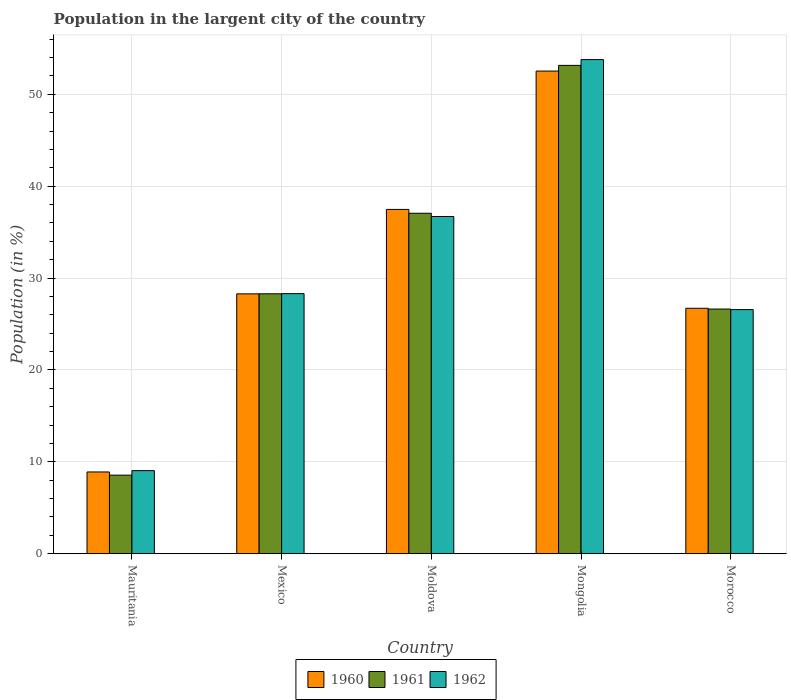How many different coloured bars are there?
Keep it short and to the point. 3. How many groups of bars are there?
Make the answer very short. 5. How many bars are there on the 4th tick from the left?
Your answer should be very brief. 3. How many bars are there on the 1st tick from the right?
Ensure brevity in your answer.  3. What is the label of the 4th group of bars from the left?
Offer a very short reply. Mongolia. In how many cases, is the number of bars for a given country not equal to the number of legend labels?
Your response must be concise. 0. What is the percentage of population in the largent city in 1960 in Mauritania?
Provide a short and direct response. 8.9. Across all countries, what is the maximum percentage of population in the largent city in 1961?
Provide a succinct answer. 53.14. Across all countries, what is the minimum percentage of population in the largent city in 1960?
Make the answer very short. 8.9. In which country was the percentage of population in the largent city in 1962 maximum?
Your answer should be compact. Mongolia. In which country was the percentage of population in the largent city in 1960 minimum?
Your answer should be very brief. Mauritania. What is the total percentage of population in the largent city in 1960 in the graph?
Your answer should be very brief. 153.88. What is the difference between the percentage of population in the largent city in 1962 in Mauritania and that in Moldova?
Ensure brevity in your answer.  -27.65. What is the difference between the percentage of population in the largent city in 1961 in Mexico and the percentage of population in the largent city in 1962 in Mongolia?
Ensure brevity in your answer.  -25.49. What is the average percentage of population in the largent city in 1962 per country?
Provide a succinct answer. 30.88. What is the difference between the percentage of population in the largent city of/in 1962 and percentage of population in the largent city of/in 1961 in Mongolia?
Your response must be concise. 0.63. What is the ratio of the percentage of population in the largent city in 1962 in Mexico to that in Moldova?
Offer a terse response. 0.77. What is the difference between the highest and the second highest percentage of population in the largent city in 1961?
Provide a succinct answer. 8.76. What is the difference between the highest and the lowest percentage of population in the largent city in 1961?
Provide a short and direct response. 44.59. What does the 2nd bar from the left in Mauritania represents?
Provide a short and direct response. 1961. How many bars are there?
Your answer should be very brief. 15. Does the graph contain any zero values?
Offer a terse response. No. Where does the legend appear in the graph?
Provide a short and direct response. Bottom center. How many legend labels are there?
Keep it short and to the point. 3. What is the title of the graph?
Your answer should be very brief. Population in the largent city of the country. Does "1986" appear as one of the legend labels in the graph?
Ensure brevity in your answer.  No. What is the Population (in %) in 1960 in Mauritania?
Offer a very short reply. 8.9. What is the Population (in %) in 1961 in Mauritania?
Provide a short and direct response. 8.55. What is the Population (in %) of 1962 in Mauritania?
Give a very brief answer. 9.04. What is the Population (in %) of 1960 in Mexico?
Make the answer very short. 28.28. What is the Population (in %) of 1961 in Mexico?
Give a very brief answer. 28.29. What is the Population (in %) in 1962 in Mexico?
Give a very brief answer. 28.31. What is the Population (in %) of 1960 in Moldova?
Provide a short and direct response. 37.47. What is the Population (in %) of 1961 in Moldova?
Provide a succinct answer. 37.05. What is the Population (in %) in 1962 in Moldova?
Give a very brief answer. 36.7. What is the Population (in %) in 1960 in Mongolia?
Provide a succinct answer. 52.52. What is the Population (in %) of 1961 in Mongolia?
Provide a short and direct response. 53.14. What is the Population (in %) in 1962 in Mongolia?
Your answer should be compact. 53.77. What is the Population (in %) in 1960 in Morocco?
Your answer should be very brief. 26.71. What is the Population (in %) of 1961 in Morocco?
Give a very brief answer. 26.63. What is the Population (in %) of 1962 in Morocco?
Keep it short and to the point. 26.57. Across all countries, what is the maximum Population (in %) of 1960?
Keep it short and to the point. 52.52. Across all countries, what is the maximum Population (in %) in 1961?
Provide a short and direct response. 53.14. Across all countries, what is the maximum Population (in %) in 1962?
Give a very brief answer. 53.77. Across all countries, what is the minimum Population (in %) of 1960?
Your answer should be compact. 8.9. Across all countries, what is the minimum Population (in %) in 1961?
Provide a succinct answer. 8.55. Across all countries, what is the minimum Population (in %) of 1962?
Your answer should be very brief. 9.04. What is the total Population (in %) of 1960 in the graph?
Your answer should be compact. 153.88. What is the total Population (in %) in 1961 in the graph?
Keep it short and to the point. 153.66. What is the total Population (in %) of 1962 in the graph?
Give a very brief answer. 154.39. What is the difference between the Population (in %) of 1960 in Mauritania and that in Mexico?
Make the answer very short. -19.38. What is the difference between the Population (in %) of 1961 in Mauritania and that in Mexico?
Your response must be concise. -19.73. What is the difference between the Population (in %) of 1962 in Mauritania and that in Mexico?
Provide a succinct answer. -19.26. What is the difference between the Population (in %) of 1960 in Mauritania and that in Moldova?
Ensure brevity in your answer.  -28.57. What is the difference between the Population (in %) in 1961 in Mauritania and that in Moldova?
Keep it short and to the point. -28.5. What is the difference between the Population (in %) in 1962 in Mauritania and that in Moldova?
Provide a succinct answer. -27.66. What is the difference between the Population (in %) of 1960 in Mauritania and that in Mongolia?
Ensure brevity in your answer.  -43.62. What is the difference between the Population (in %) of 1961 in Mauritania and that in Mongolia?
Offer a very short reply. -44.59. What is the difference between the Population (in %) of 1962 in Mauritania and that in Mongolia?
Make the answer very short. -44.73. What is the difference between the Population (in %) of 1960 in Mauritania and that in Morocco?
Provide a succinct answer. -17.81. What is the difference between the Population (in %) in 1961 in Mauritania and that in Morocco?
Provide a succinct answer. -18.08. What is the difference between the Population (in %) in 1962 in Mauritania and that in Morocco?
Your answer should be very brief. -17.53. What is the difference between the Population (in %) in 1960 in Mexico and that in Moldova?
Make the answer very short. -9.19. What is the difference between the Population (in %) in 1961 in Mexico and that in Moldova?
Offer a terse response. -8.76. What is the difference between the Population (in %) of 1962 in Mexico and that in Moldova?
Your answer should be very brief. -8.39. What is the difference between the Population (in %) in 1960 in Mexico and that in Mongolia?
Your answer should be very brief. -24.24. What is the difference between the Population (in %) of 1961 in Mexico and that in Mongolia?
Your response must be concise. -24.86. What is the difference between the Population (in %) in 1962 in Mexico and that in Mongolia?
Provide a succinct answer. -25.47. What is the difference between the Population (in %) in 1960 in Mexico and that in Morocco?
Offer a terse response. 1.57. What is the difference between the Population (in %) of 1961 in Mexico and that in Morocco?
Ensure brevity in your answer.  1.66. What is the difference between the Population (in %) of 1962 in Mexico and that in Morocco?
Your response must be concise. 1.74. What is the difference between the Population (in %) in 1960 in Moldova and that in Mongolia?
Offer a terse response. -15.05. What is the difference between the Population (in %) in 1961 in Moldova and that in Mongolia?
Keep it short and to the point. -16.09. What is the difference between the Population (in %) of 1962 in Moldova and that in Mongolia?
Your answer should be very brief. -17.08. What is the difference between the Population (in %) of 1960 in Moldova and that in Morocco?
Your answer should be very brief. 10.76. What is the difference between the Population (in %) in 1961 in Moldova and that in Morocco?
Give a very brief answer. 10.42. What is the difference between the Population (in %) in 1962 in Moldova and that in Morocco?
Your answer should be very brief. 10.13. What is the difference between the Population (in %) of 1960 in Mongolia and that in Morocco?
Your response must be concise. 25.81. What is the difference between the Population (in %) of 1961 in Mongolia and that in Morocco?
Give a very brief answer. 26.51. What is the difference between the Population (in %) in 1962 in Mongolia and that in Morocco?
Make the answer very short. 27.2. What is the difference between the Population (in %) in 1960 in Mauritania and the Population (in %) in 1961 in Mexico?
Your answer should be very brief. -19.39. What is the difference between the Population (in %) in 1960 in Mauritania and the Population (in %) in 1962 in Mexico?
Give a very brief answer. -19.41. What is the difference between the Population (in %) in 1961 in Mauritania and the Population (in %) in 1962 in Mexico?
Your answer should be compact. -19.75. What is the difference between the Population (in %) of 1960 in Mauritania and the Population (in %) of 1961 in Moldova?
Your response must be concise. -28.15. What is the difference between the Population (in %) of 1960 in Mauritania and the Population (in %) of 1962 in Moldova?
Provide a short and direct response. -27.8. What is the difference between the Population (in %) in 1961 in Mauritania and the Population (in %) in 1962 in Moldova?
Offer a terse response. -28.15. What is the difference between the Population (in %) of 1960 in Mauritania and the Population (in %) of 1961 in Mongolia?
Make the answer very short. -44.24. What is the difference between the Population (in %) of 1960 in Mauritania and the Population (in %) of 1962 in Mongolia?
Your answer should be compact. -44.87. What is the difference between the Population (in %) in 1961 in Mauritania and the Population (in %) in 1962 in Mongolia?
Provide a succinct answer. -45.22. What is the difference between the Population (in %) in 1960 in Mauritania and the Population (in %) in 1961 in Morocco?
Ensure brevity in your answer.  -17.73. What is the difference between the Population (in %) in 1960 in Mauritania and the Population (in %) in 1962 in Morocco?
Ensure brevity in your answer.  -17.67. What is the difference between the Population (in %) in 1961 in Mauritania and the Population (in %) in 1962 in Morocco?
Make the answer very short. -18.02. What is the difference between the Population (in %) in 1960 in Mexico and the Population (in %) in 1961 in Moldova?
Make the answer very short. -8.77. What is the difference between the Population (in %) of 1960 in Mexico and the Population (in %) of 1962 in Moldova?
Give a very brief answer. -8.42. What is the difference between the Population (in %) in 1961 in Mexico and the Population (in %) in 1962 in Moldova?
Offer a very short reply. -8.41. What is the difference between the Population (in %) of 1960 in Mexico and the Population (in %) of 1961 in Mongolia?
Provide a short and direct response. -24.86. What is the difference between the Population (in %) of 1960 in Mexico and the Population (in %) of 1962 in Mongolia?
Your answer should be very brief. -25.49. What is the difference between the Population (in %) in 1961 in Mexico and the Population (in %) in 1962 in Mongolia?
Give a very brief answer. -25.49. What is the difference between the Population (in %) in 1960 in Mexico and the Population (in %) in 1961 in Morocco?
Keep it short and to the point. 1.65. What is the difference between the Population (in %) in 1960 in Mexico and the Population (in %) in 1962 in Morocco?
Keep it short and to the point. 1.71. What is the difference between the Population (in %) in 1961 in Mexico and the Population (in %) in 1962 in Morocco?
Ensure brevity in your answer.  1.72. What is the difference between the Population (in %) of 1960 in Moldova and the Population (in %) of 1961 in Mongolia?
Offer a very short reply. -15.67. What is the difference between the Population (in %) of 1960 in Moldova and the Population (in %) of 1962 in Mongolia?
Your response must be concise. -16.3. What is the difference between the Population (in %) of 1961 in Moldova and the Population (in %) of 1962 in Mongolia?
Your answer should be very brief. -16.72. What is the difference between the Population (in %) of 1960 in Moldova and the Population (in %) of 1961 in Morocco?
Keep it short and to the point. 10.84. What is the difference between the Population (in %) in 1960 in Moldova and the Population (in %) in 1962 in Morocco?
Ensure brevity in your answer.  10.9. What is the difference between the Population (in %) in 1961 in Moldova and the Population (in %) in 1962 in Morocco?
Offer a very short reply. 10.48. What is the difference between the Population (in %) in 1960 in Mongolia and the Population (in %) in 1961 in Morocco?
Provide a succinct answer. 25.89. What is the difference between the Population (in %) in 1960 in Mongolia and the Population (in %) in 1962 in Morocco?
Make the answer very short. 25.96. What is the difference between the Population (in %) of 1961 in Mongolia and the Population (in %) of 1962 in Morocco?
Your response must be concise. 26.57. What is the average Population (in %) of 1960 per country?
Make the answer very short. 30.78. What is the average Population (in %) in 1961 per country?
Keep it short and to the point. 30.73. What is the average Population (in %) of 1962 per country?
Make the answer very short. 30.88. What is the difference between the Population (in %) in 1960 and Population (in %) in 1961 in Mauritania?
Offer a terse response. 0.35. What is the difference between the Population (in %) of 1960 and Population (in %) of 1962 in Mauritania?
Offer a very short reply. -0.14. What is the difference between the Population (in %) in 1961 and Population (in %) in 1962 in Mauritania?
Keep it short and to the point. -0.49. What is the difference between the Population (in %) of 1960 and Population (in %) of 1961 in Mexico?
Your answer should be compact. -0.01. What is the difference between the Population (in %) of 1960 and Population (in %) of 1962 in Mexico?
Ensure brevity in your answer.  -0.02. What is the difference between the Population (in %) of 1961 and Population (in %) of 1962 in Mexico?
Keep it short and to the point. -0.02. What is the difference between the Population (in %) in 1960 and Population (in %) in 1961 in Moldova?
Provide a short and direct response. 0.42. What is the difference between the Population (in %) of 1960 and Population (in %) of 1962 in Moldova?
Your response must be concise. 0.77. What is the difference between the Population (in %) of 1961 and Population (in %) of 1962 in Moldova?
Your answer should be compact. 0.35. What is the difference between the Population (in %) of 1960 and Population (in %) of 1961 in Mongolia?
Offer a very short reply. -0.62. What is the difference between the Population (in %) in 1960 and Population (in %) in 1962 in Mongolia?
Give a very brief answer. -1.25. What is the difference between the Population (in %) of 1961 and Population (in %) of 1962 in Mongolia?
Your response must be concise. -0.63. What is the difference between the Population (in %) in 1960 and Population (in %) in 1961 in Morocco?
Your response must be concise. 0.08. What is the difference between the Population (in %) in 1960 and Population (in %) in 1962 in Morocco?
Offer a very short reply. 0.14. What is the difference between the Population (in %) in 1961 and Population (in %) in 1962 in Morocco?
Provide a succinct answer. 0.06. What is the ratio of the Population (in %) in 1960 in Mauritania to that in Mexico?
Offer a very short reply. 0.31. What is the ratio of the Population (in %) in 1961 in Mauritania to that in Mexico?
Your answer should be very brief. 0.3. What is the ratio of the Population (in %) of 1962 in Mauritania to that in Mexico?
Ensure brevity in your answer.  0.32. What is the ratio of the Population (in %) in 1960 in Mauritania to that in Moldova?
Make the answer very short. 0.24. What is the ratio of the Population (in %) of 1961 in Mauritania to that in Moldova?
Give a very brief answer. 0.23. What is the ratio of the Population (in %) of 1962 in Mauritania to that in Moldova?
Offer a terse response. 0.25. What is the ratio of the Population (in %) in 1960 in Mauritania to that in Mongolia?
Keep it short and to the point. 0.17. What is the ratio of the Population (in %) in 1961 in Mauritania to that in Mongolia?
Ensure brevity in your answer.  0.16. What is the ratio of the Population (in %) in 1962 in Mauritania to that in Mongolia?
Your response must be concise. 0.17. What is the ratio of the Population (in %) of 1960 in Mauritania to that in Morocco?
Offer a terse response. 0.33. What is the ratio of the Population (in %) in 1961 in Mauritania to that in Morocco?
Make the answer very short. 0.32. What is the ratio of the Population (in %) in 1962 in Mauritania to that in Morocco?
Provide a succinct answer. 0.34. What is the ratio of the Population (in %) in 1960 in Mexico to that in Moldova?
Provide a succinct answer. 0.75. What is the ratio of the Population (in %) of 1961 in Mexico to that in Moldova?
Make the answer very short. 0.76. What is the ratio of the Population (in %) of 1962 in Mexico to that in Moldova?
Your answer should be very brief. 0.77. What is the ratio of the Population (in %) in 1960 in Mexico to that in Mongolia?
Your answer should be compact. 0.54. What is the ratio of the Population (in %) of 1961 in Mexico to that in Mongolia?
Your response must be concise. 0.53. What is the ratio of the Population (in %) in 1962 in Mexico to that in Mongolia?
Give a very brief answer. 0.53. What is the ratio of the Population (in %) in 1960 in Mexico to that in Morocco?
Your response must be concise. 1.06. What is the ratio of the Population (in %) of 1961 in Mexico to that in Morocco?
Provide a succinct answer. 1.06. What is the ratio of the Population (in %) of 1962 in Mexico to that in Morocco?
Your answer should be very brief. 1.07. What is the ratio of the Population (in %) of 1960 in Moldova to that in Mongolia?
Offer a terse response. 0.71. What is the ratio of the Population (in %) of 1961 in Moldova to that in Mongolia?
Give a very brief answer. 0.7. What is the ratio of the Population (in %) of 1962 in Moldova to that in Mongolia?
Provide a succinct answer. 0.68. What is the ratio of the Population (in %) of 1960 in Moldova to that in Morocco?
Make the answer very short. 1.4. What is the ratio of the Population (in %) of 1961 in Moldova to that in Morocco?
Keep it short and to the point. 1.39. What is the ratio of the Population (in %) of 1962 in Moldova to that in Morocco?
Your response must be concise. 1.38. What is the ratio of the Population (in %) of 1960 in Mongolia to that in Morocco?
Offer a terse response. 1.97. What is the ratio of the Population (in %) in 1961 in Mongolia to that in Morocco?
Provide a succinct answer. 2. What is the ratio of the Population (in %) in 1962 in Mongolia to that in Morocco?
Offer a terse response. 2.02. What is the difference between the highest and the second highest Population (in %) in 1960?
Provide a succinct answer. 15.05. What is the difference between the highest and the second highest Population (in %) of 1961?
Offer a terse response. 16.09. What is the difference between the highest and the second highest Population (in %) in 1962?
Your answer should be very brief. 17.08. What is the difference between the highest and the lowest Population (in %) in 1960?
Offer a terse response. 43.62. What is the difference between the highest and the lowest Population (in %) in 1961?
Keep it short and to the point. 44.59. What is the difference between the highest and the lowest Population (in %) in 1962?
Your answer should be very brief. 44.73. 